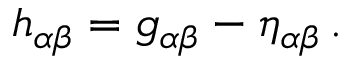<formula> <loc_0><loc_0><loc_500><loc_500>h _ { \alpha \beta } = g _ { \alpha \beta } - \eta _ { \alpha \beta } \, .</formula> 